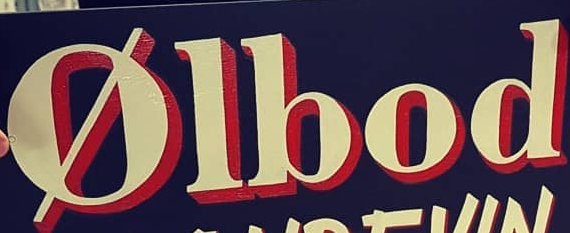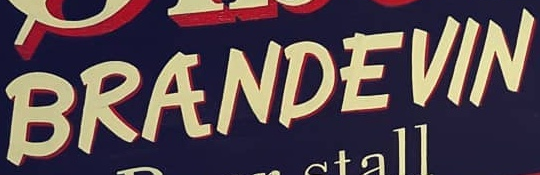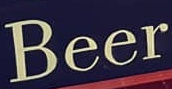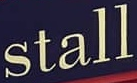What words can you see in these images in sequence, separated by a semicolon? Ølbod; BRANDEVIN; Beer; stall 